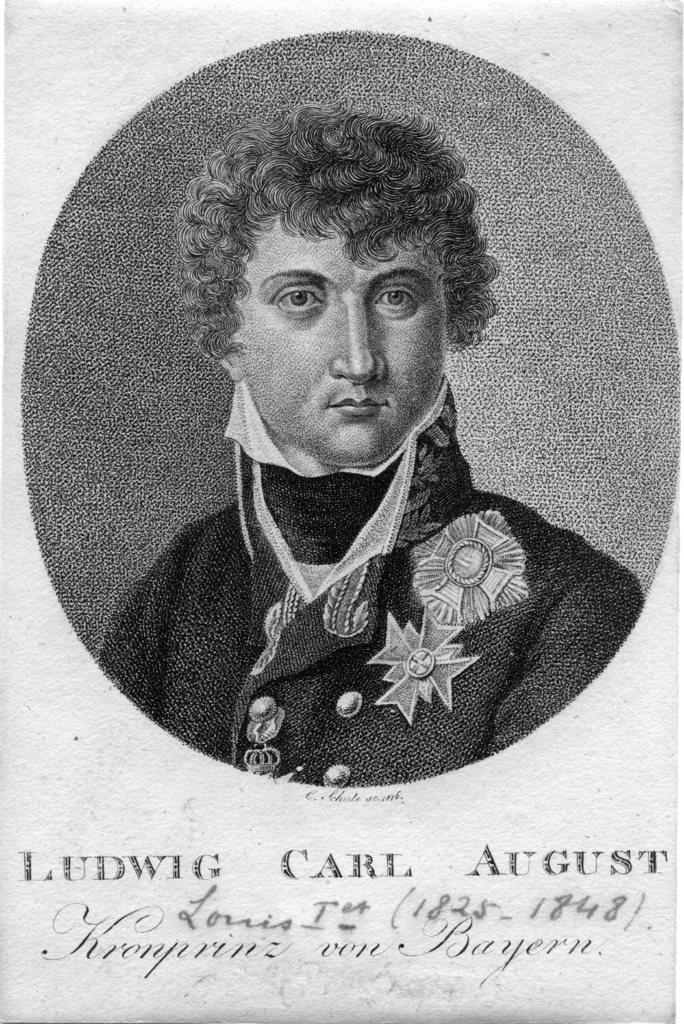What is the main subject of the image? There is a depiction of a person in the center of the image. Is there any text associated with the image? Yes, there is text written at the bottom of the image. How many times does the person jump in the image? There is no indication of the person jumping in the image; they are depicted in a stationary position. What type of design is used for the person's clothing in the image? The provided facts do not mention any details about the person's clothing, so it is not possible to answer this question. 